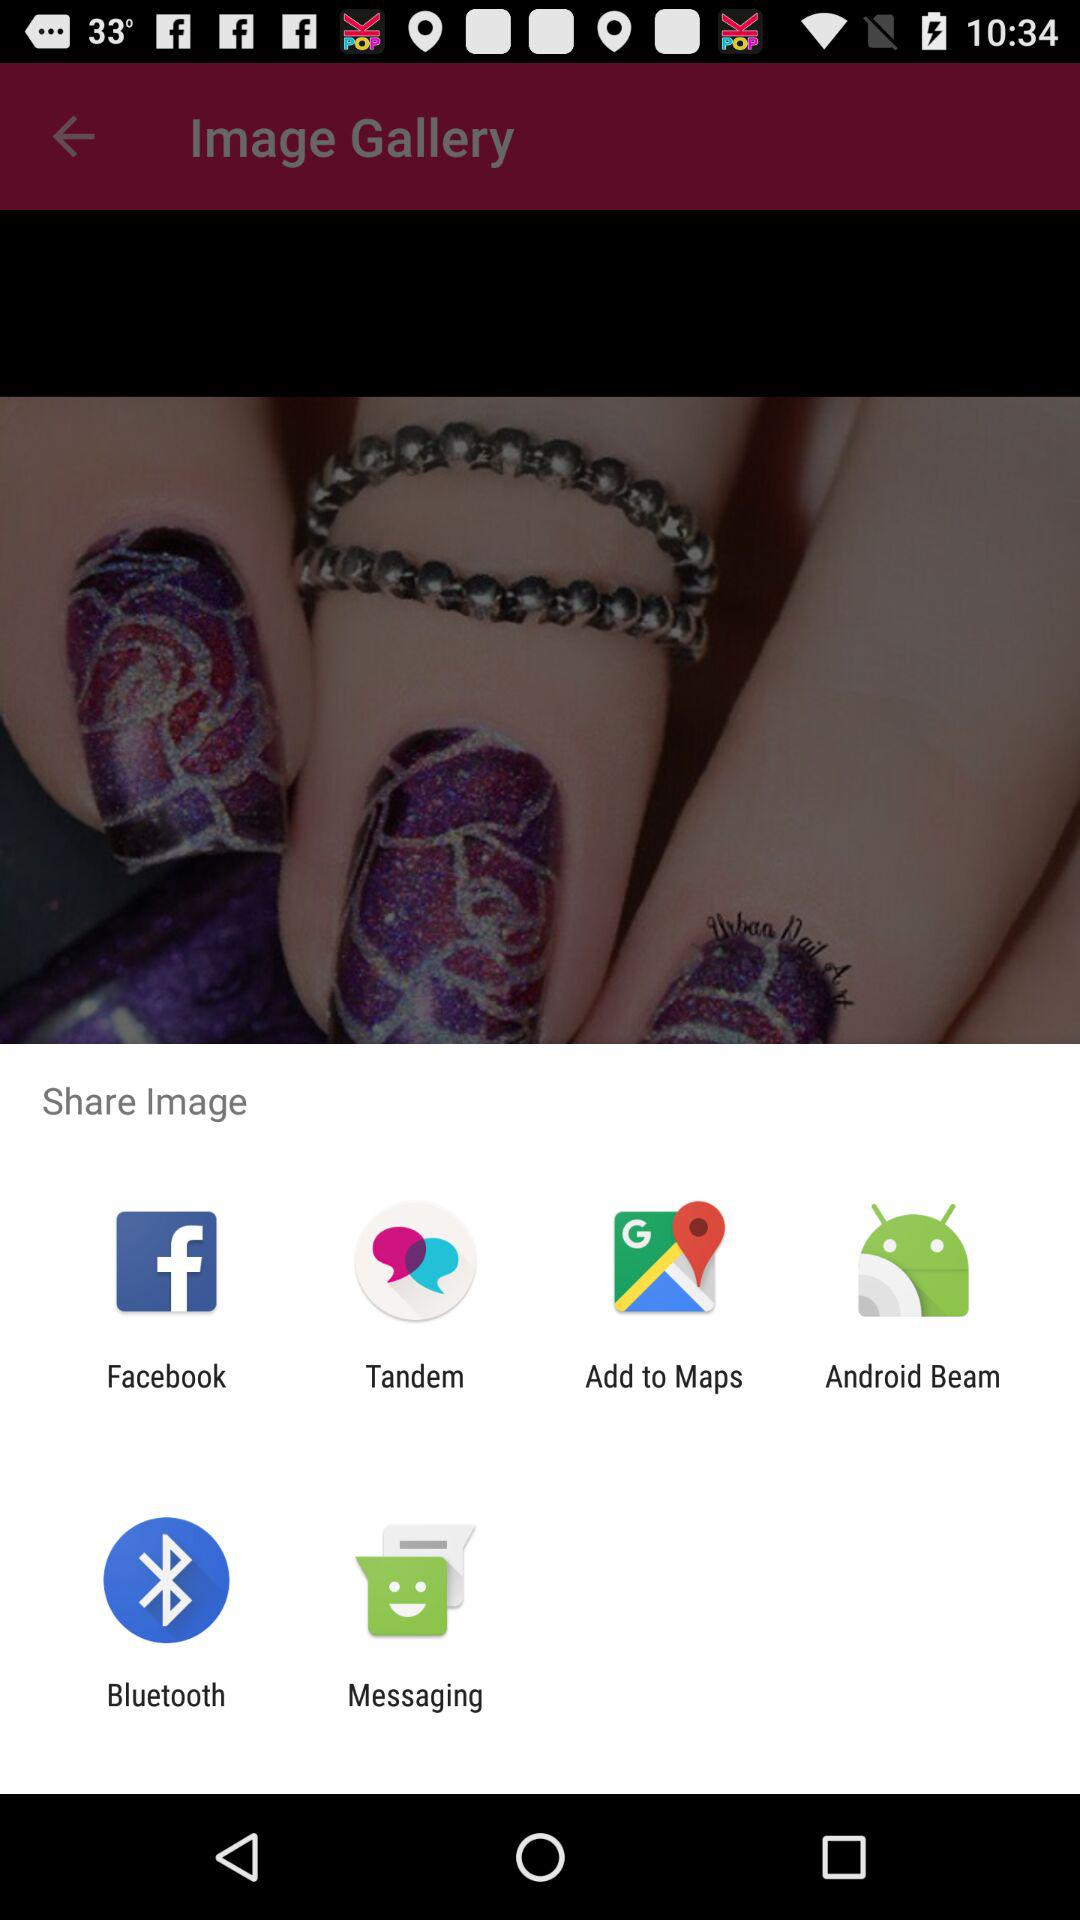How many share options are available?
Answer the question using a single word or phrase. 6 